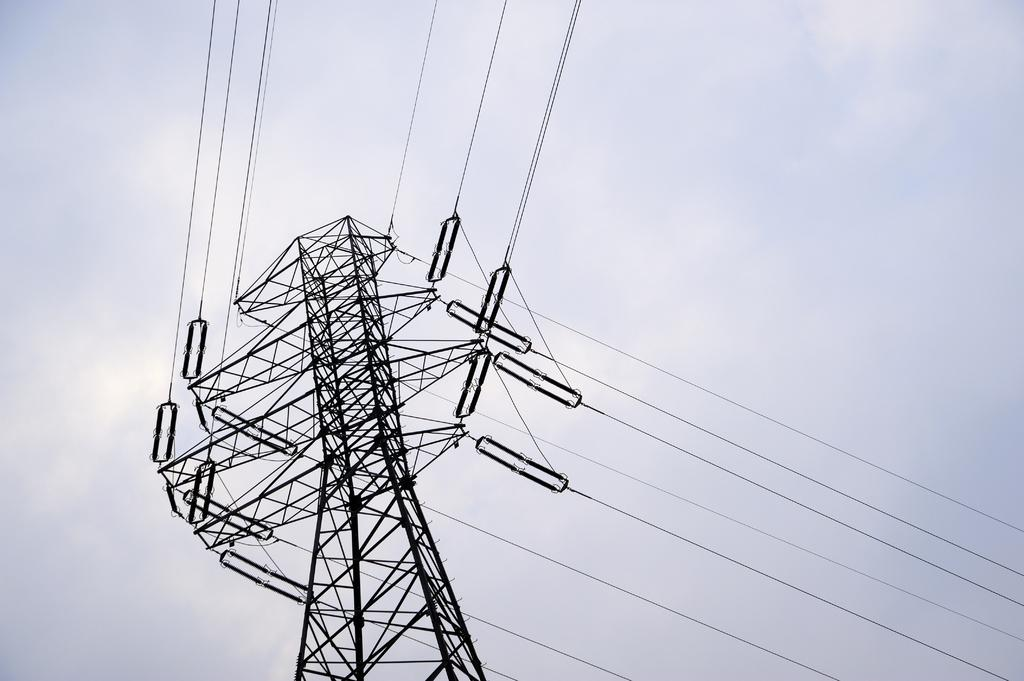What is the main object in the image? There is a transmission pole in the image. What can be seen in the background of the image? The sky is visible in the background of the image. How is the sky described in the image? The color of the sky is described as white. Where is the tin located in the image? There is no tin present in the image. What type of transportation can be seen at the airport in the image? There is no airport or transportation present in the image. Can you describe the girl's clothing in the image? There is no girl present in the image. 